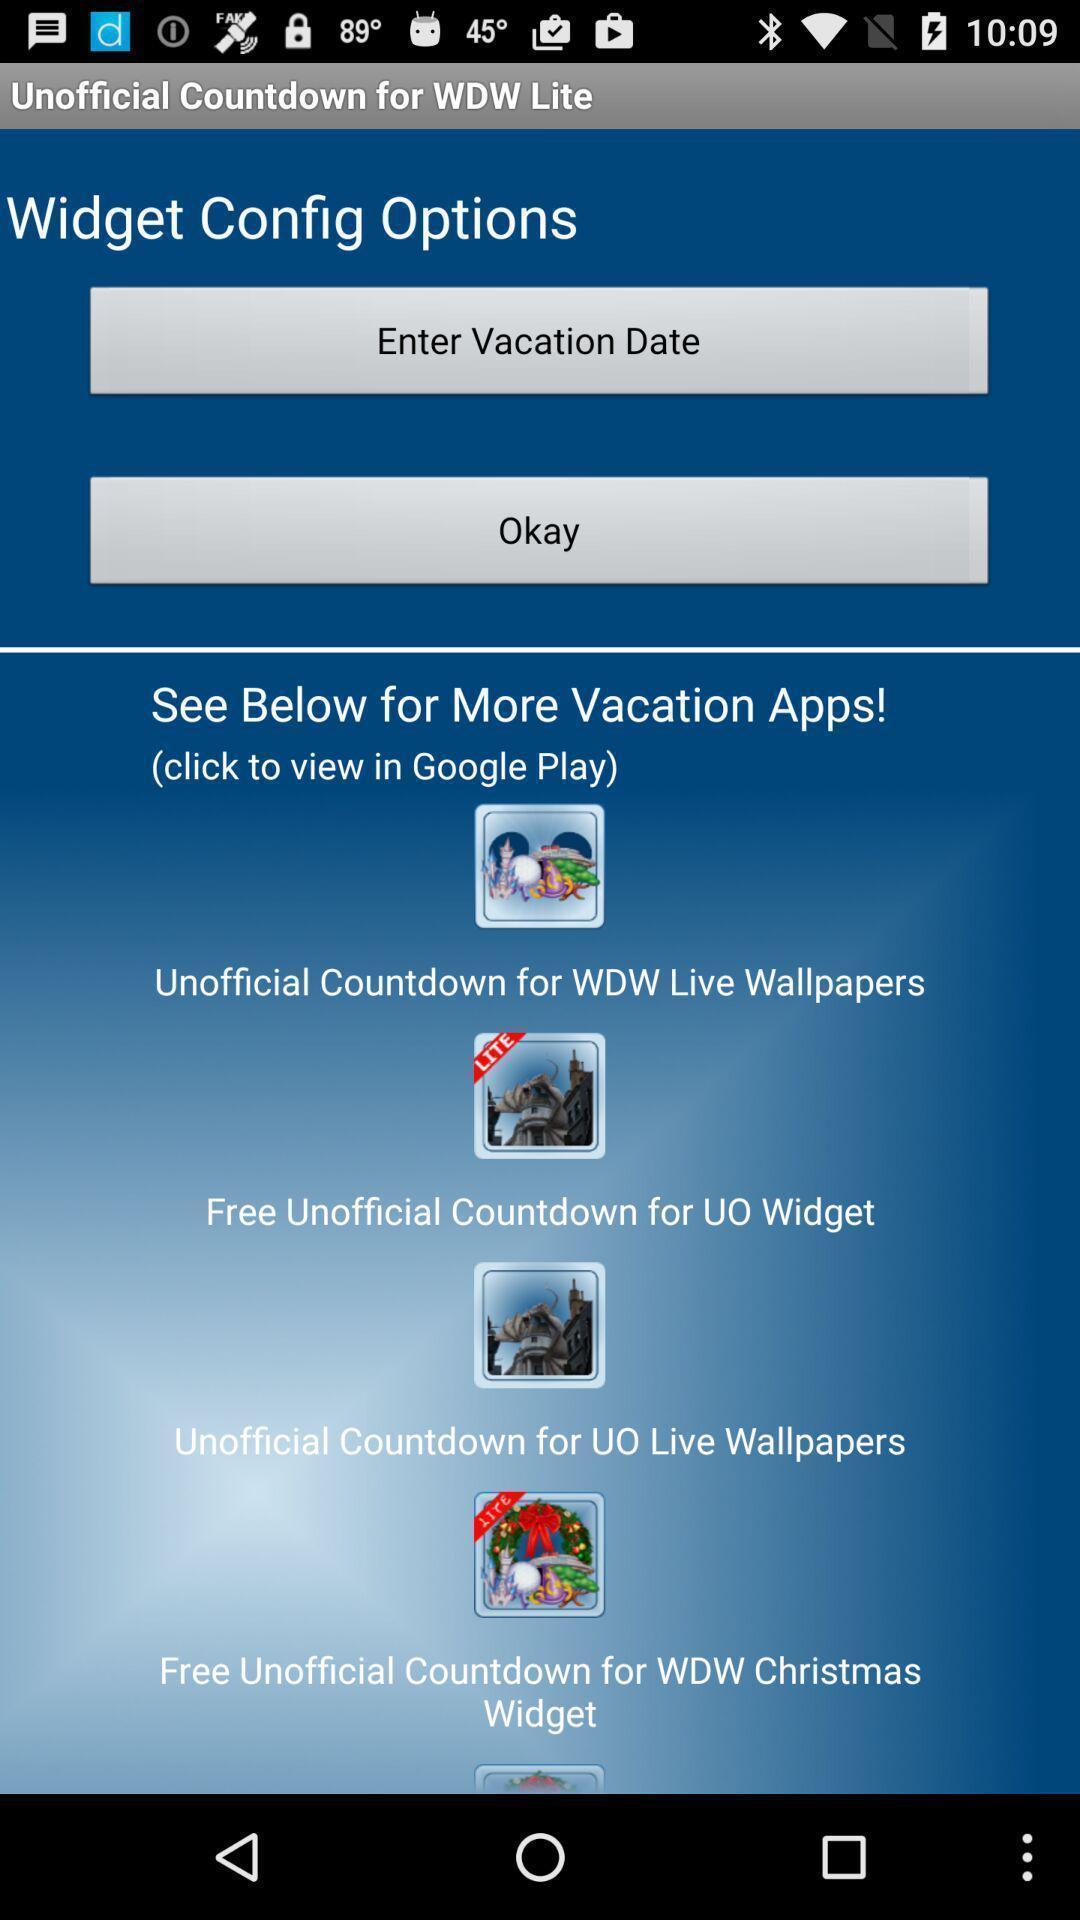Summarize the main components in this picture. Page showing various holiday options. 